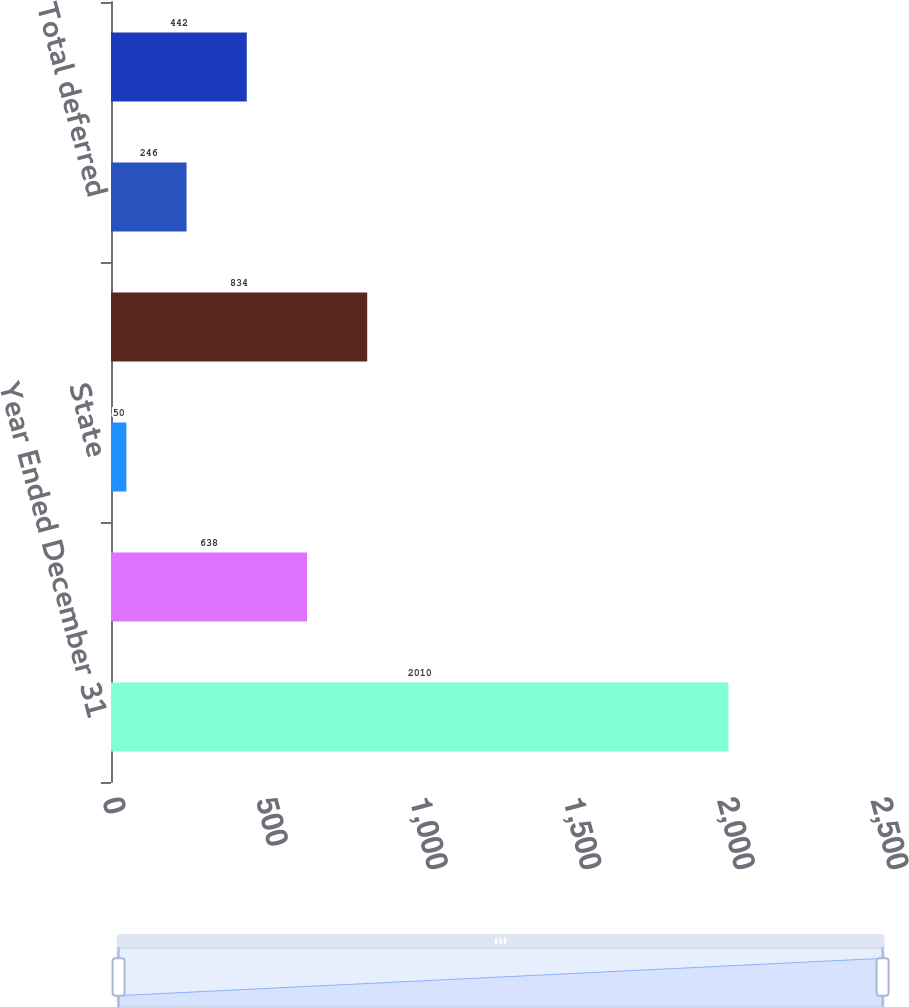Convert chart. <chart><loc_0><loc_0><loc_500><loc_500><bar_chart><fcel>Year Ended December 31<fcel>Federal<fcel>State<fcel>Total current<fcel>Total deferred<fcel>Taxes on income<nl><fcel>2010<fcel>638<fcel>50<fcel>834<fcel>246<fcel>442<nl></chart> 